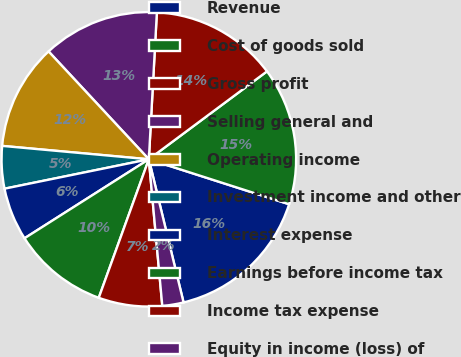<chart> <loc_0><loc_0><loc_500><loc_500><pie_chart><fcel>Revenue<fcel>Cost of goods sold<fcel>Gross profit<fcel>Selling general and<fcel>Operating income<fcel>Investment income and other<fcel>Interest expense<fcel>Earnings before income tax<fcel>Income tax expense<fcel>Equity in income (loss) of<nl><fcel>16.28%<fcel>15.12%<fcel>13.95%<fcel>12.79%<fcel>11.63%<fcel>4.65%<fcel>5.81%<fcel>10.47%<fcel>6.98%<fcel>2.33%<nl></chart> 